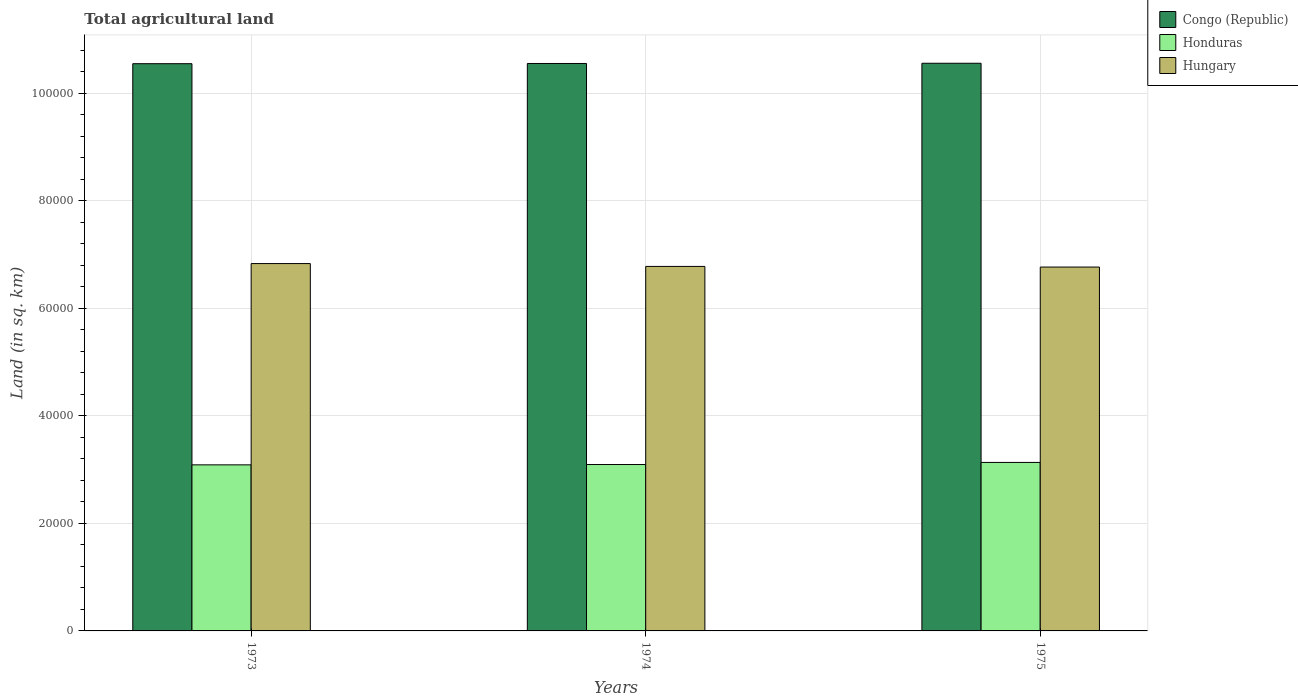How many different coloured bars are there?
Provide a succinct answer. 3. How many groups of bars are there?
Provide a short and direct response. 3. What is the label of the 3rd group of bars from the left?
Provide a succinct answer. 1975. In how many cases, is the number of bars for a given year not equal to the number of legend labels?
Offer a terse response. 0. What is the total agricultural land in Congo (Republic) in 1974?
Provide a succinct answer. 1.06e+05. Across all years, what is the maximum total agricultural land in Hungary?
Provide a succinct answer. 6.84e+04. Across all years, what is the minimum total agricultural land in Honduras?
Provide a short and direct response. 3.09e+04. In which year was the total agricultural land in Hungary minimum?
Keep it short and to the point. 1975. What is the total total agricultural land in Hungary in the graph?
Your response must be concise. 2.04e+05. What is the difference between the total agricultural land in Congo (Republic) in 1973 and that in 1974?
Offer a very short reply. -40. What is the difference between the total agricultural land in Honduras in 1975 and the total agricultural land in Congo (Republic) in 1974?
Your answer should be very brief. -7.42e+04. What is the average total agricultural land in Honduras per year?
Your answer should be compact. 3.11e+04. In the year 1975, what is the difference between the total agricultural land in Congo (Republic) and total agricultural land in Honduras?
Keep it short and to the point. 7.43e+04. What is the ratio of the total agricultural land in Honduras in 1973 to that in 1974?
Ensure brevity in your answer.  1. What is the difference between the highest and the second highest total agricultural land in Congo (Republic)?
Your answer should be compact. 40. What is the difference between the highest and the lowest total agricultural land in Honduras?
Offer a terse response. 450. What does the 2nd bar from the left in 1974 represents?
Offer a terse response. Honduras. What does the 3rd bar from the right in 1975 represents?
Ensure brevity in your answer.  Congo (Republic). Is it the case that in every year, the sum of the total agricultural land in Hungary and total agricultural land in Honduras is greater than the total agricultural land in Congo (Republic)?
Your answer should be very brief. No. How many bars are there?
Your answer should be very brief. 9. How many years are there in the graph?
Your answer should be very brief. 3. What is the difference between two consecutive major ticks on the Y-axis?
Provide a succinct answer. 2.00e+04. Are the values on the major ticks of Y-axis written in scientific E-notation?
Your response must be concise. No. What is the title of the graph?
Your answer should be compact. Total agricultural land. What is the label or title of the X-axis?
Provide a short and direct response. Years. What is the label or title of the Y-axis?
Provide a short and direct response. Land (in sq. km). What is the Land (in sq. km) of Congo (Republic) in 1973?
Provide a succinct answer. 1.06e+05. What is the Land (in sq. km) of Honduras in 1973?
Provide a short and direct response. 3.09e+04. What is the Land (in sq. km) of Hungary in 1973?
Offer a terse response. 6.84e+04. What is the Land (in sq. km) of Congo (Republic) in 1974?
Your response must be concise. 1.06e+05. What is the Land (in sq. km) in Honduras in 1974?
Make the answer very short. 3.10e+04. What is the Land (in sq. km) in Hungary in 1974?
Your answer should be very brief. 6.78e+04. What is the Land (in sq. km) in Congo (Republic) in 1975?
Your answer should be very brief. 1.06e+05. What is the Land (in sq. km) in Honduras in 1975?
Keep it short and to the point. 3.14e+04. What is the Land (in sq. km) of Hungary in 1975?
Your answer should be compact. 6.77e+04. Across all years, what is the maximum Land (in sq. km) of Congo (Republic)?
Offer a very short reply. 1.06e+05. Across all years, what is the maximum Land (in sq. km) in Honduras?
Give a very brief answer. 3.14e+04. Across all years, what is the maximum Land (in sq. km) of Hungary?
Your answer should be compact. 6.84e+04. Across all years, what is the minimum Land (in sq. km) in Congo (Republic)?
Provide a succinct answer. 1.06e+05. Across all years, what is the minimum Land (in sq. km) in Honduras?
Provide a succinct answer. 3.09e+04. Across all years, what is the minimum Land (in sq. km) of Hungary?
Make the answer very short. 6.77e+04. What is the total Land (in sq. km) in Congo (Republic) in the graph?
Give a very brief answer. 3.17e+05. What is the total Land (in sq. km) in Honduras in the graph?
Provide a succinct answer. 9.32e+04. What is the total Land (in sq. km) of Hungary in the graph?
Offer a very short reply. 2.04e+05. What is the difference between the Land (in sq. km) in Honduras in 1973 and that in 1974?
Your answer should be very brief. -60. What is the difference between the Land (in sq. km) in Hungary in 1973 and that in 1974?
Ensure brevity in your answer.  530. What is the difference between the Land (in sq. km) of Congo (Republic) in 1973 and that in 1975?
Your answer should be very brief. -80. What is the difference between the Land (in sq. km) in Honduras in 1973 and that in 1975?
Give a very brief answer. -450. What is the difference between the Land (in sq. km) in Hungary in 1973 and that in 1975?
Your response must be concise. 650. What is the difference between the Land (in sq. km) in Congo (Republic) in 1974 and that in 1975?
Provide a succinct answer. -40. What is the difference between the Land (in sq. km) in Honduras in 1974 and that in 1975?
Provide a succinct answer. -390. What is the difference between the Land (in sq. km) in Hungary in 1974 and that in 1975?
Provide a succinct answer. 120. What is the difference between the Land (in sq. km) in Congo (Republic) in 1973 and the Land (in sq. km) in Honduras in 1974?
Offer a very short reply. 7.46e+04. What is the difference between the Land (in sq. km) of Congo (Republic) in 1973 and the Land (in sq. km) of Hungary in 1974?
Your answer should be very brief. 3.77e+04. What is the difference between the Land (in sq. km) of Honduras in 1973 and the Land (in sq. km) of Hungary in 1974?
Your answer should be compact. -3.69e+04. What is the difference between the Land (in sq. km) in Congo (Republic) in 1973 and the Land (in sq. km) in Honduras in 1975?
Provide a succinct answer. 7.42e+04. What is the difference between the Land (in sq. km) of Congo (Republic) in 1973 and the Land (in sq. km) of Hungary in 1975?
Make the answer very short. 3.78e+04. What is the difference between the Land (in sq. km) in Honduras in 1973 and the Land (in sq. km) in Hungary in 1975?
Your answer should be very brief. -3.68e+04. What is the difference between the Land (in sq. km) of Congo (Republic) in 1974 and the Land (in sq. km) of Honduras in 1975?
Make the answer very short. 7.42e+04. What is the difference between the Land (in sq. km) of Congo (Republic) in 1974 and the Land (in sq. km) of Hungary in 1975?
Ensure brevity in your answer.  3.79e+04. What is the difference between the Land (in sq. km) of Honduras in 1974 and the Land (in sq. km) of Hungary in 1975?
Provide a short and direct response. -3.67e+04. What is the average Land (in sq. km) in Congo (Republic) per year?
Offer a very short reply. 1.06e+05. What is the average Land (in sq. km) in Honduras per year?
Your answer should be very brief. 3.11e+04. What is the average Land (in sq. km) in Hungary per year?
Offer a very short reply. 6.80e+04. In the year 1973, what is the difference between the Land (in sq. km) in Congo (Republic) and Land (in sq. km) in Honduras?
Provide a succinct answer. 7.46e+04. In the year 1973, what is the difference between the Land (in sq. km) in Congo (Republic) and Land (in sq. km) in Hungary?
Provide a short and direct response. 3.72e+04. In the year 1973, what is the difference between the Land (in sq. km) in Honduras and Land (in sq. km) in Hungary?
Provide a succinct answer. -3.74e+04. In the year 1974, what is the difference between the Land (in sq. km) of Congo (Republic) and Land (in sq. km) of Honduras?
Your answer should be very brief. 7.46e+04. In the year 1974, what is the difference between the Land (in sq. km) in Congo (Republic) and Land (in sq. km) in Hungary?
Provide a short and direct response. 3.78e+04. In the year 1974, what is the difference between the Land (in sq. km) of Honduras and Land (in sq. km) of Hungary?
Your answer should be very brief. -3.69e+04. In the year 1975, what is the difference between the Land (in sq. km) of Congo (Republic) and Land (in sq. km) of Honduras?
Your response must be concise. 7.43e+04. In the year 1975, what is the difference between the Land (in sq. km) of Congo (Republic) and Land (in sq. km) of Hungary?
Provide a short and direct response. 3.79e+04. In the year 1975, what is the difference between the Land (in sq. km) in Honduras and Land (in sq. km) in Hungary?
Keep it short and to the point. -3.64e+04. What is the ratio of the Land (in sq. km) of Honduras in 1973 to that in 1974?
Your answer should be very brief. 1. What is the ratio of the Land (in sq. km) of Honduras in 1973 to that in 1975?
Make the answer very short. 0.99. What is the ratio of the Land (in sq. km) in Hungary in 1973 to that in 1975?
Ensure brevity in your answer.  1.01. What is the ratio of the Land (in sq. km) in Congo (Republic) in 1974 to that in 1975?
Make the answer very short. 1. What is the ratio of the Land (in sq. km) of Honduras in 1974 to that in 1975?
Offer a terse response. 0.99. What is the difference between the highest and the second highest Land (in sq. km) in Honduras?
Make the answer very short. 390. What is the difference between the highest and the second highest Land (in sq. km) of Hungary?
Your response must be concise. 530. What is the difference between the highest and the lowest Land (in sq. km) of Congo (Republic)?
Make the answer very short. 80. What is the difference between the highest and the lowest Land (in sq. km) in Honduras?
Ensure brevity in your answer.  450. What is the difference between the highest and the lowest Land (in sq. km) of Hungary?
Give a very brief answer. 650. 